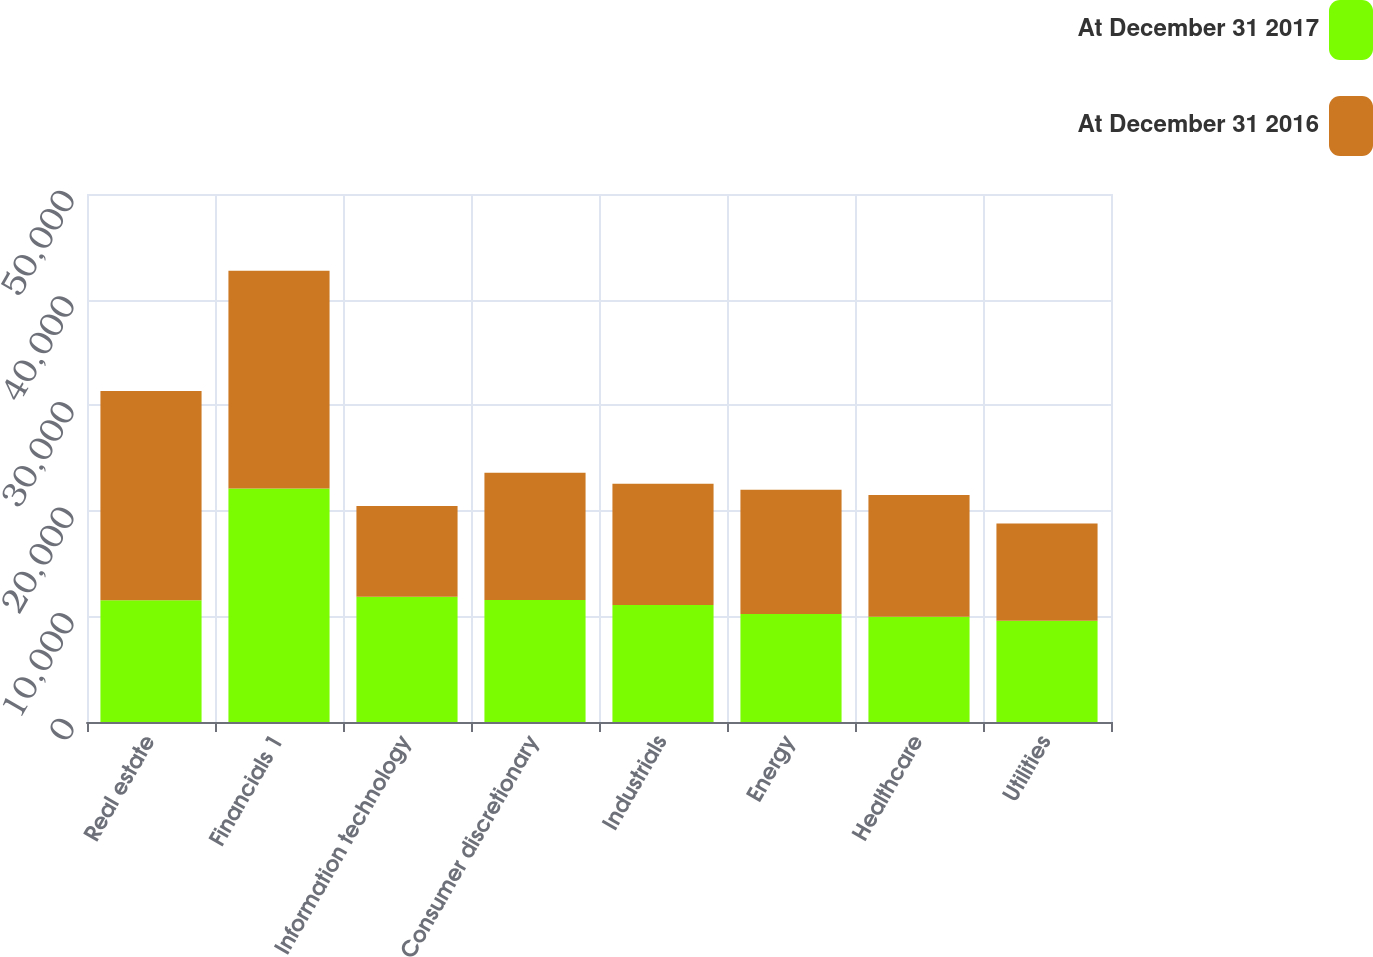<chart> <loc_0><loc_0><loc_500><loc_500><stacked_bar_chart><ecel><fcel>Real estate<fcel>Financials 1<fcel>Information technology<fcel>Consumer discretionary<fcel>Industrials<fcel>Energy<fcel>Healthcare<fcel>Utilities<nl><fcel>At December 31 2017<fcel>11534<fcel>22112<fcel>11862<fcel>11555<fcel>11090<fcel>10233<fcel>9956<fcel>9592<nl><fcel>At December 31 2016<fcel>19807<fcel>20624<fcel>8602<fcel>12059<fcel>11465<fcel>11757<fcel>11534<fcel>9216<nl></chart> 